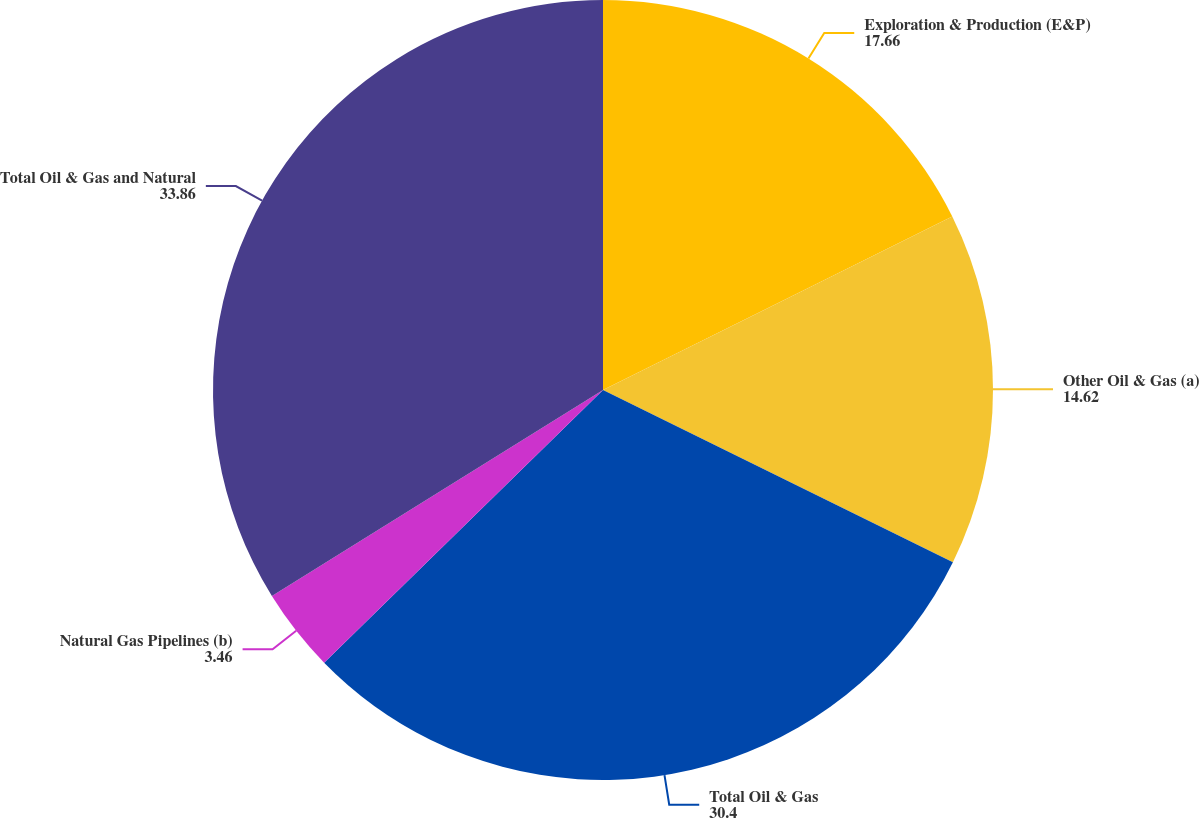Convert chart. <chart><loc_0><loc_0><loc_500><loc_500><pie_chart><fcel>Exploration & Production (E&P)<fcel>Other Oil & Gas (a)<fcel>Total Oil & Gas<fcel>Natural Gas Pipelines (b)<fcel>Total Oil & Gas and Natural<nl><fcel>17.66%<fcel>14.62%<fcel>30.4%<fcel>3.46%<fcel>33.86%<nl></chart> 